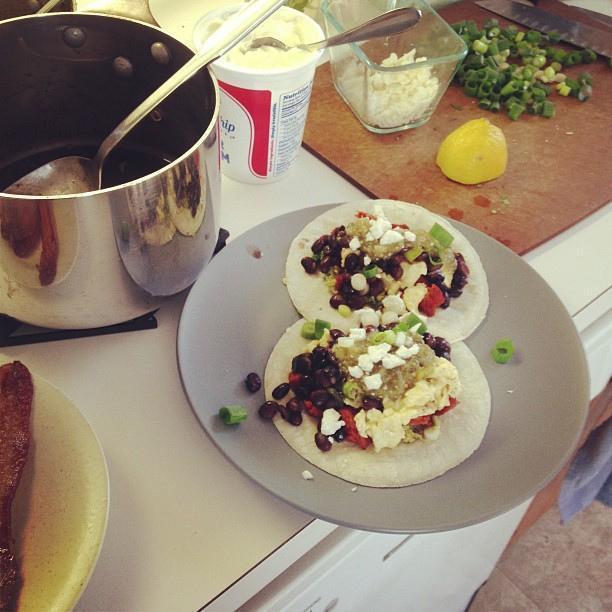How many bowls can you see?
Give a very brief answer. 2. How many spoons are visible?
Give a very brief answer. 2. 